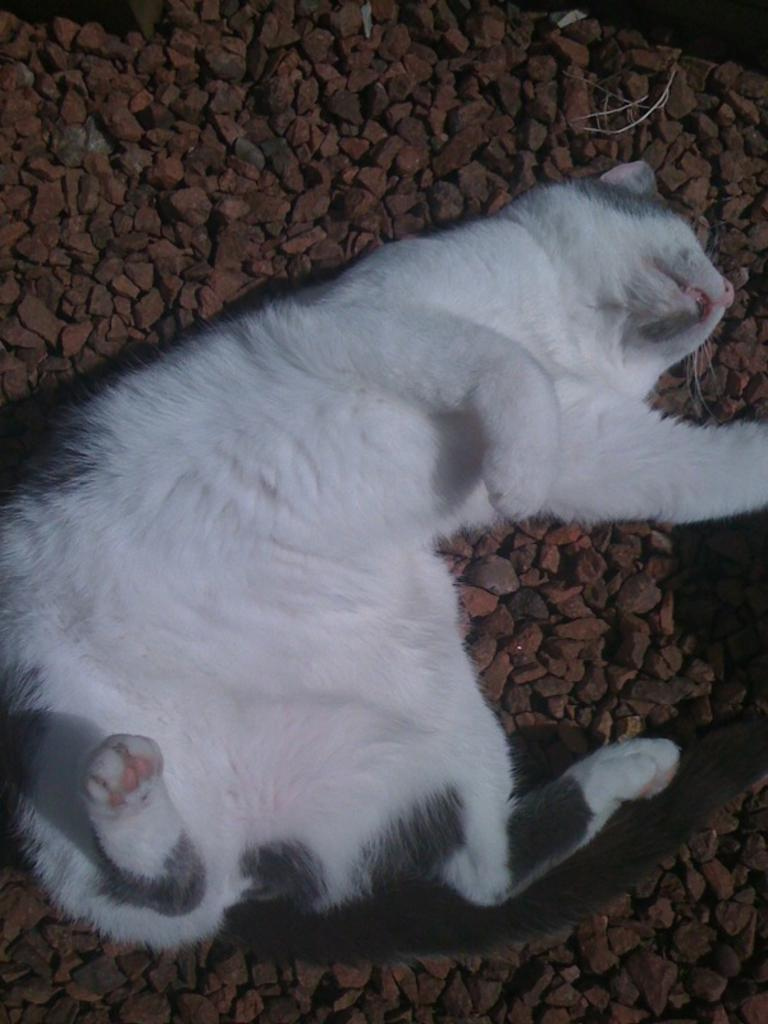What type of animal is in the image? There is a cat in the image. What is the cat doing in the image? The cat is lying on stones. What is the cat's reaction to the idea of starting a new hobby in the image? There is no information about the cat's reaction to a new hobby or any ideas in the image; it simply shows the cat lying on stones. 